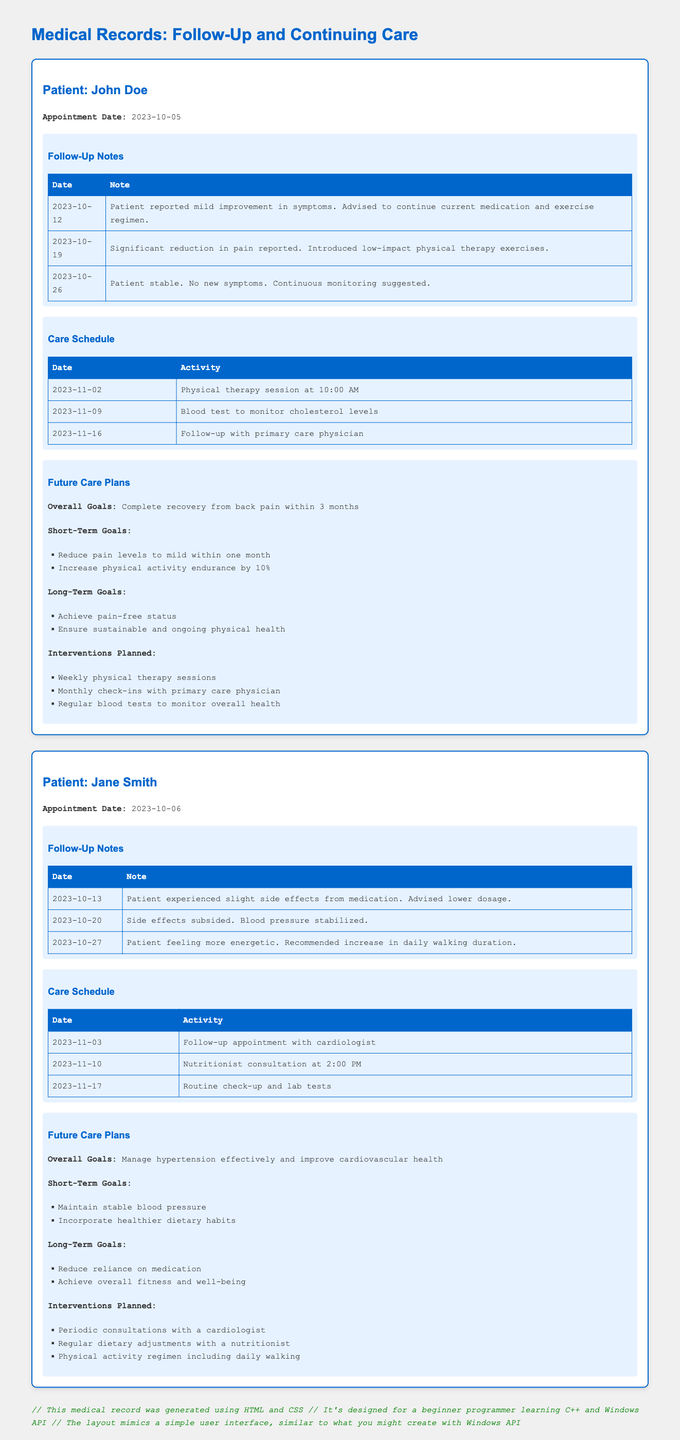What is the name of the first patient? The name of the first patient listed in the document is John Doe.
Answer: John Doe What was the appointment date for Jane Smith? The appointment date for Jane Smith can be found under her details in the document, which is 2023-10-06.
Answer: 2023-10-06 How many follow-up notes are recorded for John Doe? The follow-up notes section for John Doe contains three notes; they can be counted from the table in the section.
Answer: 3 What is the overall goal for Jane Smith's future care plans? The overall goal for Jane Smith focusing on managing her health is mentioned in the future care plans section.
Answer: Manage hypertension effectively and improve cardiovascular health What date is the physical therapy session scheduled for John Doe? The care schedule for John Doe includes a physical therapy session noted as occurring on 2023-11-02.
Answer: 2023-11-02 What intervention is planned for Jane Smith? Interventions planned for Jane Smith are listed in the future care plans, and one of them is periodic consultations with a cardiologist.
Answer: Periodic consultations with a cardiologist How often will John Doe have physical therapy sessions? The planned interventions for John Doe indicate that he will have weekly physical therapy sessions.
Answer: Weekly What was noted about Jane Smith's blood pressure on 2023-10-20? The follow-up notes for Jane Smith include a reference to her blood pressure stabilizing on that date.
Answer: Blood pressure stabilized What type of document is this? The document is designed to present a specific kind of medical information regarding patient care and follow-up appointments.
Answer: Medical record 